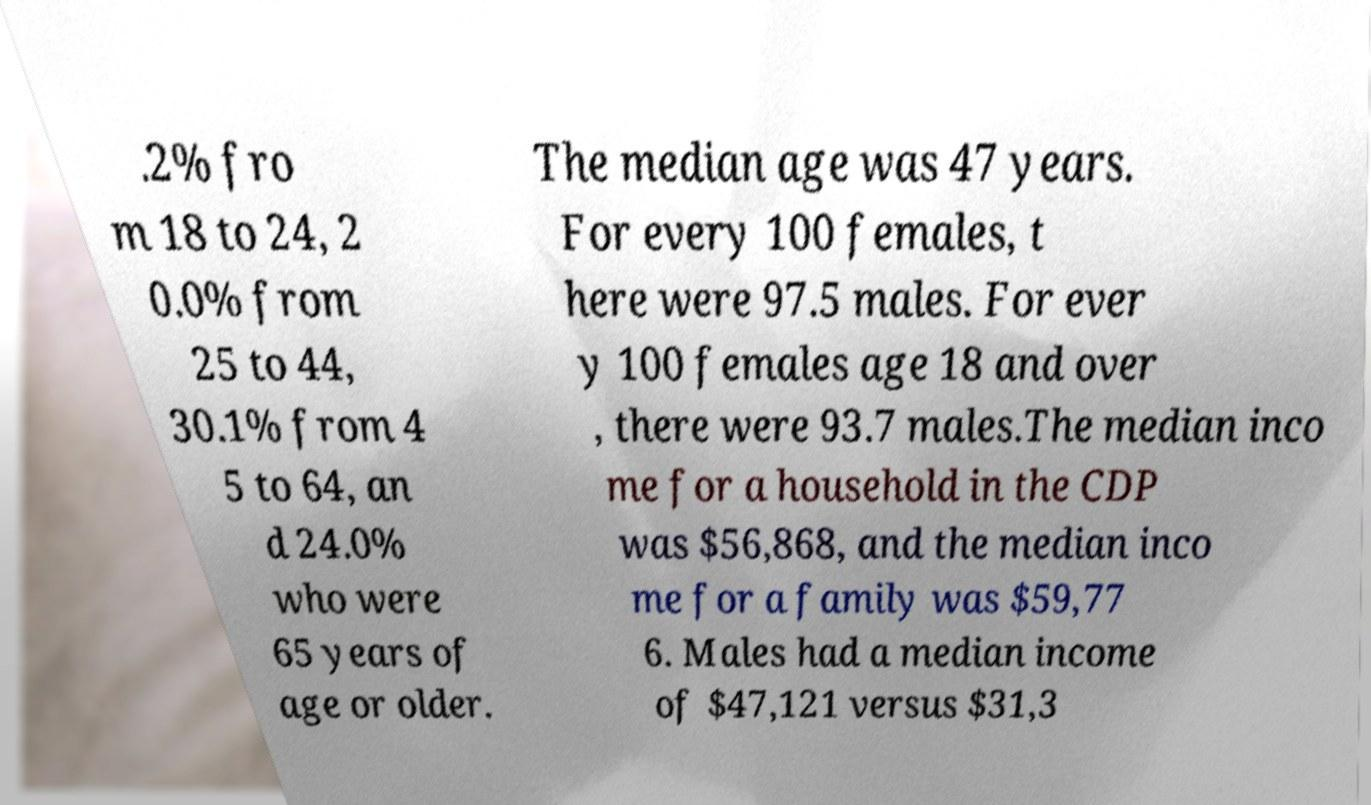Could you extract and type out the text from this image? .2% fro m 18 to 24, 2 0.0% from 25 to 44, 30.1% from 4 5 to 64, an d 24.0% who were 65 years of age or older. The median age was 47 years. For every 100 females, t here were 97.5 males. For ever y 100 females age 18 and over , there were 93.7 males.The median inco me for a household in the CDP was $56,868, and the median inco me for a family was $59,77 6. Males had a median income of $47,121 versus $31,3 